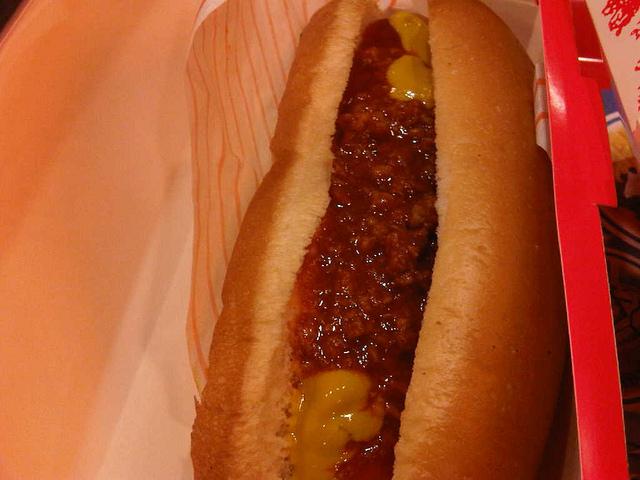How many hot dogs are there?
Give a very brief answer. 1. What is on the hotdog?
Concise answer only. Chili. What kind of toppings are on the hot dog?
Answer briefly. Chili and mustard. What is the red stuff on the hot dog?
Keep it brief. Chili. Do you like that type of hot dog?
Concise answer only. Yes. Are there onions on the hot dog?
Give a very brief answer. No. What topping is on the hot dog?
Answer briefly. Chili. Is it tasty?
Short answer required. Yes. 